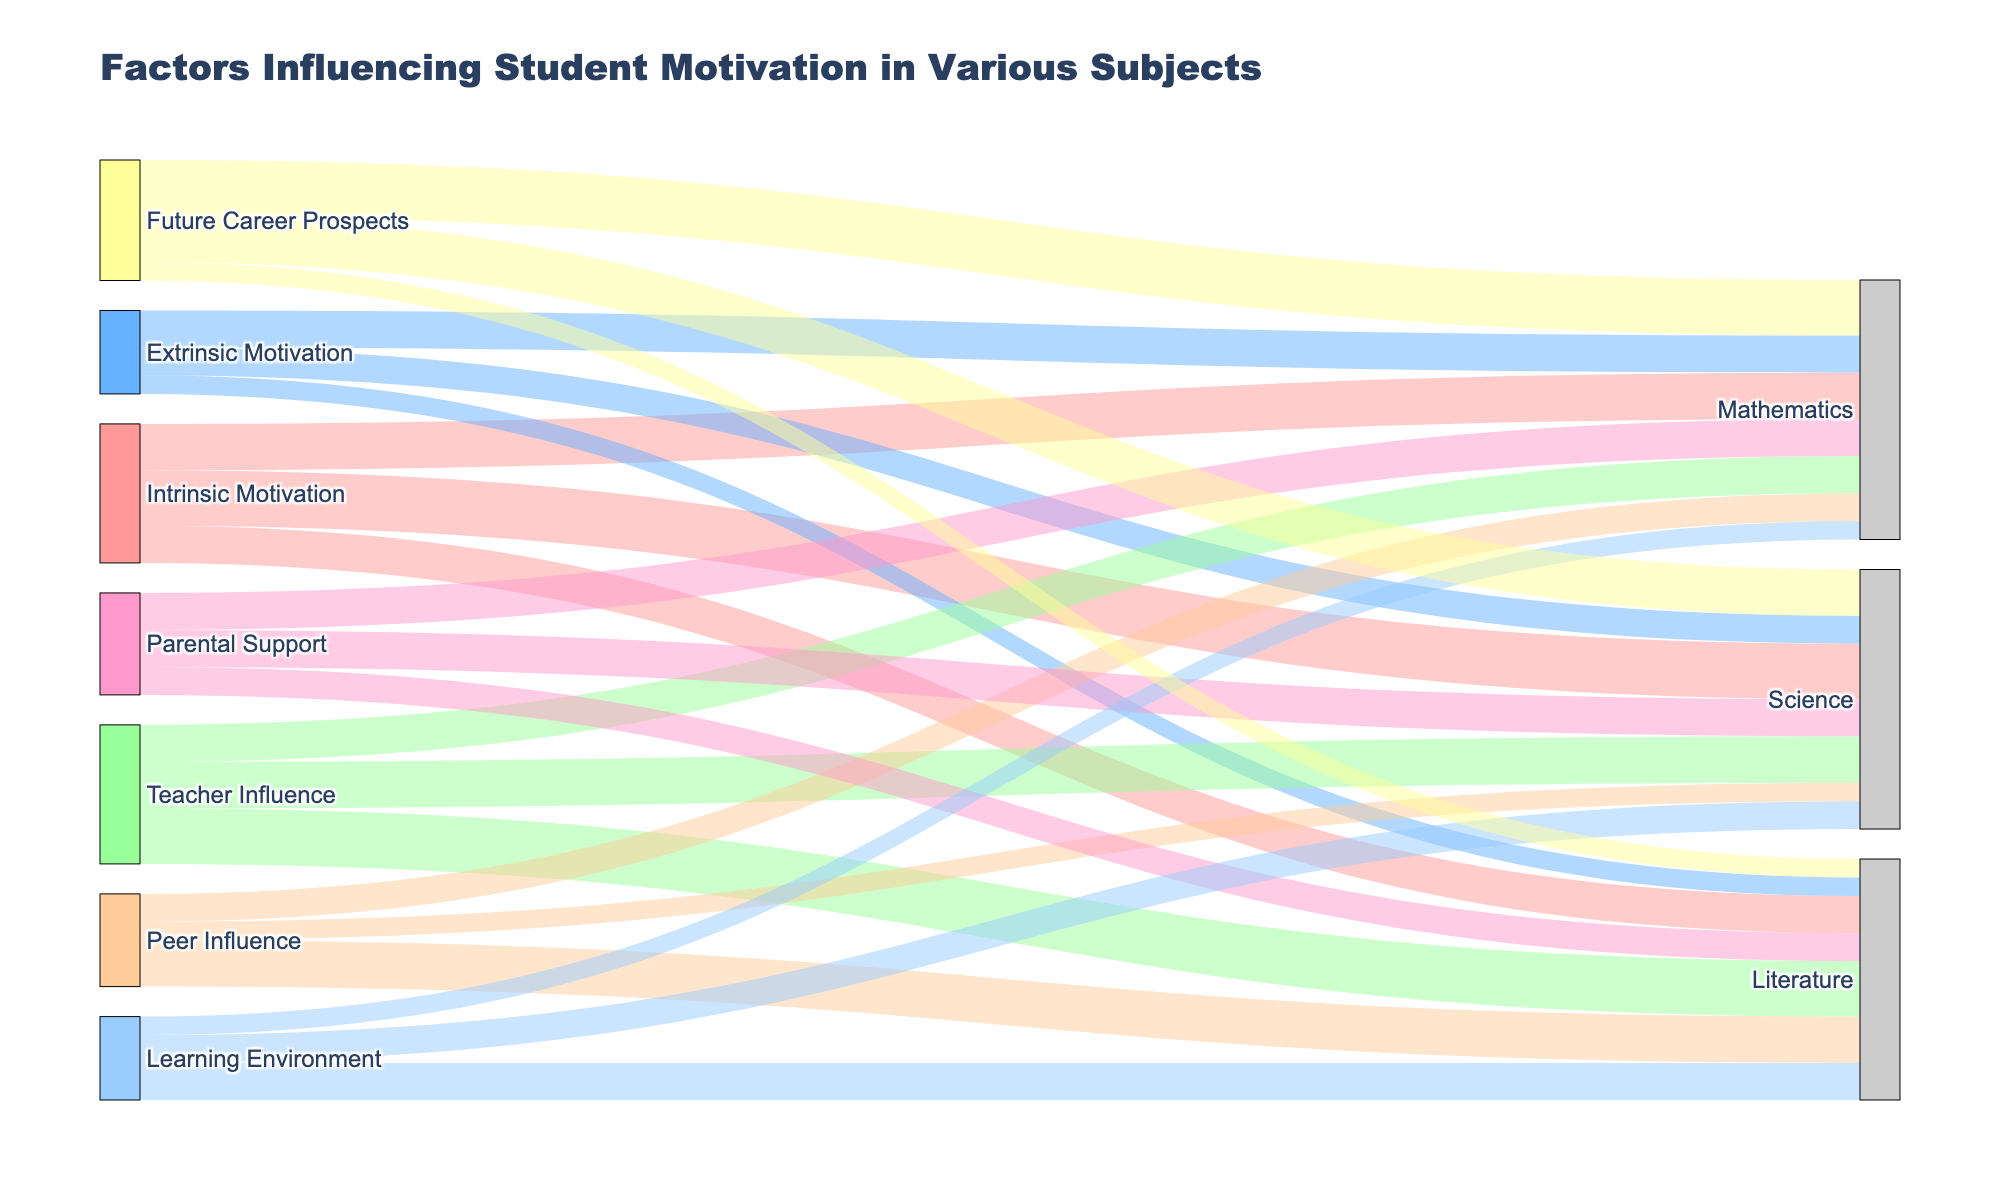What is the title of the Sankey Diagram? The title of a plot is usually displayed at the top, and in this case, it should reflect what the diagram represents. The title specifically provided in the layout update of the code is "Factors Influencing Student Motivation in Various Subjects."
Answer: Factors Influencing Student Motivation in Various Subjects What are the primary sources of student motivation according to the diagram? In a Sankey Diagram, primary sources are depicted on the left side. Observing the left side of the diagram, we can identify the sources: Intrinsic Motivation, Extrinsic Motivation, Teacher Influence, Peer Influence, Parental Support, Learning Environment, and Future Career Prospects.
Answer: Intrinsic Motivation, Extrinsic Motivation, Teacher Influence, Peer Influence, Parental Support, Learning Environment, and Future Career Prospects Which subject has the highest total influence from all sources? To determine this, we sum the values of all links entering each subject (Science, Mathematics, Literature). By comparing these sums, we find the subject with the highest total influence. Science: 30+15+25+10+20+15+25 = 140; Mathematics: 25+20+20+15+20+10+30 = 140; Literature: 20+10+30+25+15+20+10 = 130. Science and Mathematics have the highest total influence.
Answer: Science and Mathematics What is the difference in the influence of Intrinsic Motivation on Science and Literature? Find the values corresponding to Intrinsic Motivation's influence on Science and Literature from the diagram. For Science, it's 30; for Literature, it's 20. The difference is calculated as 30 - 20.
Answer: 10 How does Peer Influence on Literature compare to Peer Influence on Mathematics? See the values corresponding to Peer Influence on both Literature and Mathematics in the diagram. Peer Influence on Literature is 25, and on Mathematics is 15. Comparing these values, Peer Influence on Literature is greater.
Answer: Peer Influence on Literature is greater Which source of motivation has the least influence on Mathematics? Examine all links leading to Mathematics and identify the source with the smallest value. Intrinsic Motivation: 25; Extrinsic Motivation: 20; Teacher Influence: 20; Peer Influence: 15; Parental Support: 20; Learning Environment: 10; Future Career Prospects: 30. The smallest value is from Learning Environment.
Answer: Learning Environment How is the influence of Extrinsic Motivation distributed across the subjects? Look at how Extrinsic Motivation flows into each subject and note their respective values. For Science: 15, for Mathematics: 20, for Literature: 10. This shows how Extrinsic Motivation is distributed.
Answer: Science: 15, Mathematics: 20, Literature: 10 What is the total influence of Parental Support across all subjects? Sum up the values from Parental Support to each subject. For Science: 20, for Mathematics: 20, for Literature: 15. Add these: 20 + 20 + 15 = 55.
Answer: 55 